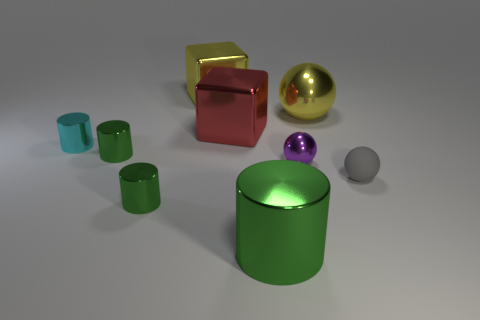There is a cyan thing left of the gray rubber thing; is its size the same as the ball on the left side of the big yellow metal ball?
Your response must be concise. Yes. Are there more large red metal cubes left of the large metallic ball than yellow objects left of the cyan metallic object?
Your answer should be very brief. Yes. What number of other objects are the same color as the tiny rubber sphere?
Provide a short and direct response. 0. Do the large ball and the big object behind the yellow metallic ball have the same color?
Provide a short and direct response. Yes. There is a green metallic object behind the tiny purple object; what number of metal cylinders are to the left of it?
Ensure brevity in your answer.  1. Are there any other things that have the same material as the gray sphere?
Your answer should be compact. No. What is the material of the small gray thing on the right side of the tiny metallic object on the right side of the green metal cylinder on the right side of the red metal block?
Offer a very short reply. Rubber. There is a thing that is both to the right of the tiny purple object and in front of the small cyan thing; what material is it?
Offer a terse response. Rubber. How many other objects have the same shape as the small purple thing?
Provide a succinct answer. 2. How big is the yellow object to the right of the big thing in front of the cyan cylinder?
Provide a succinct answer. Large. 